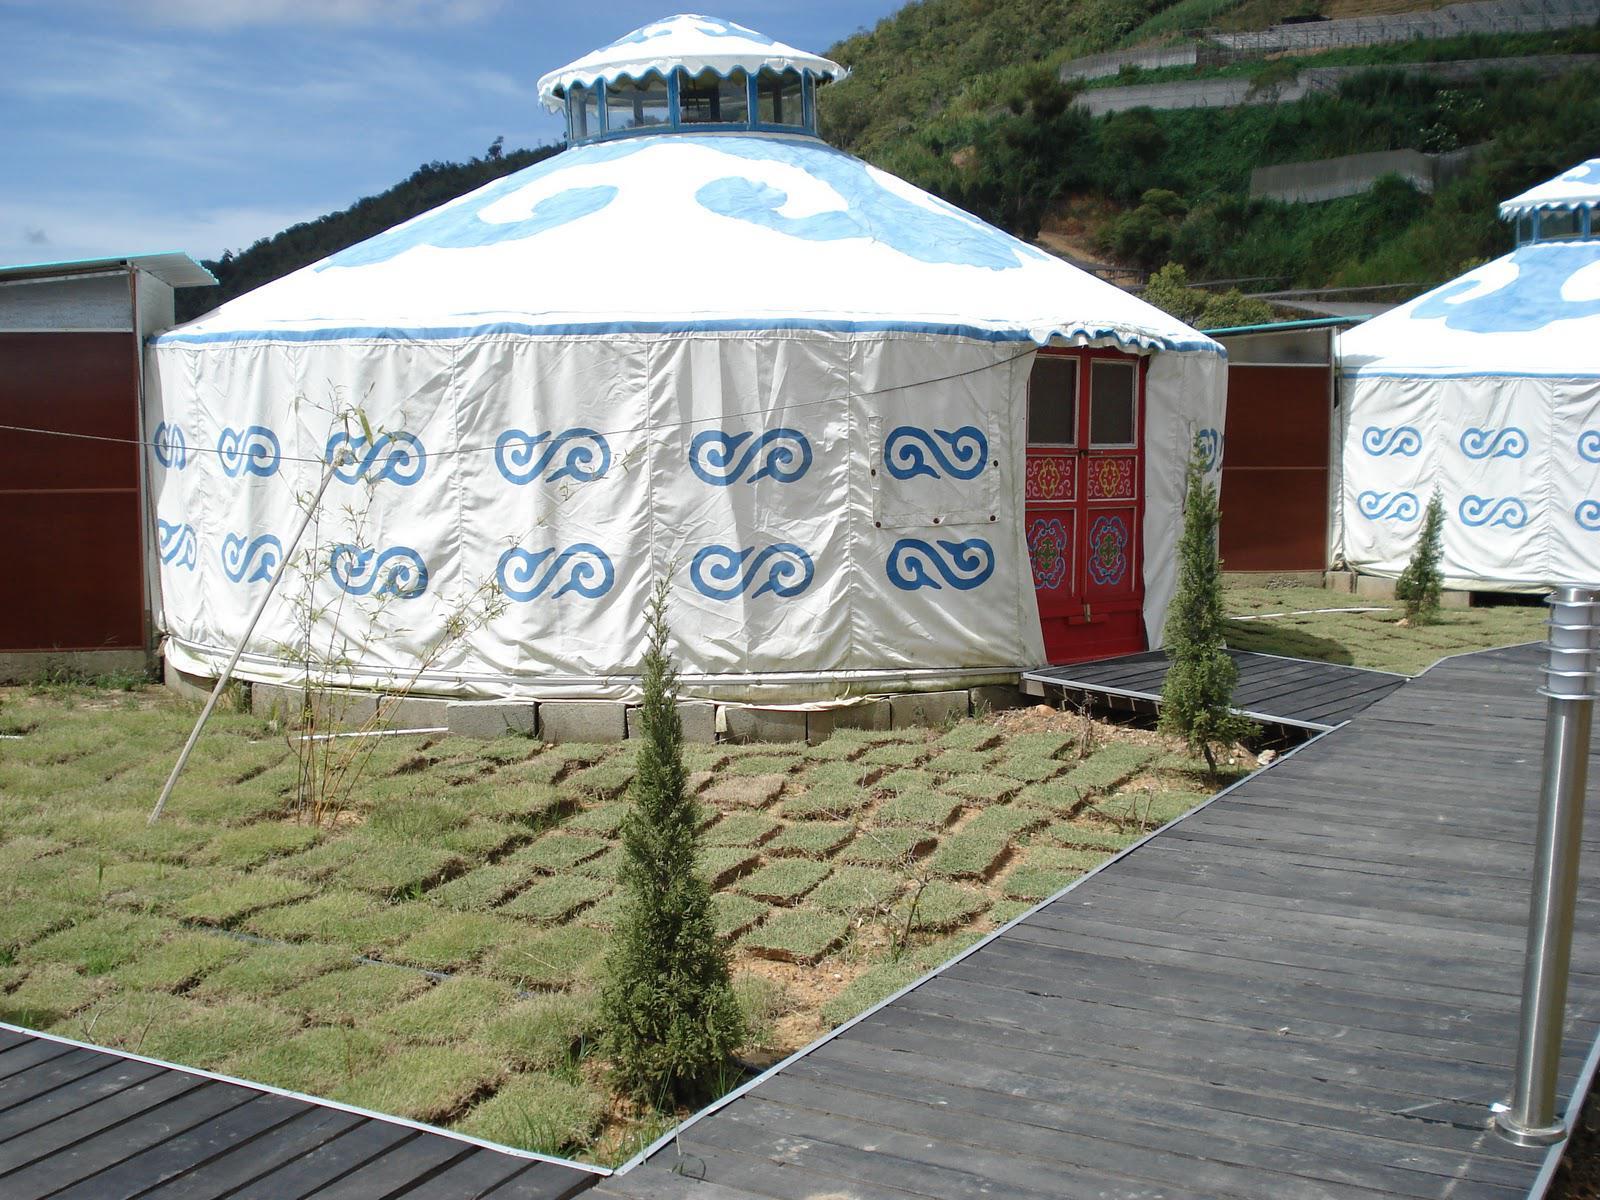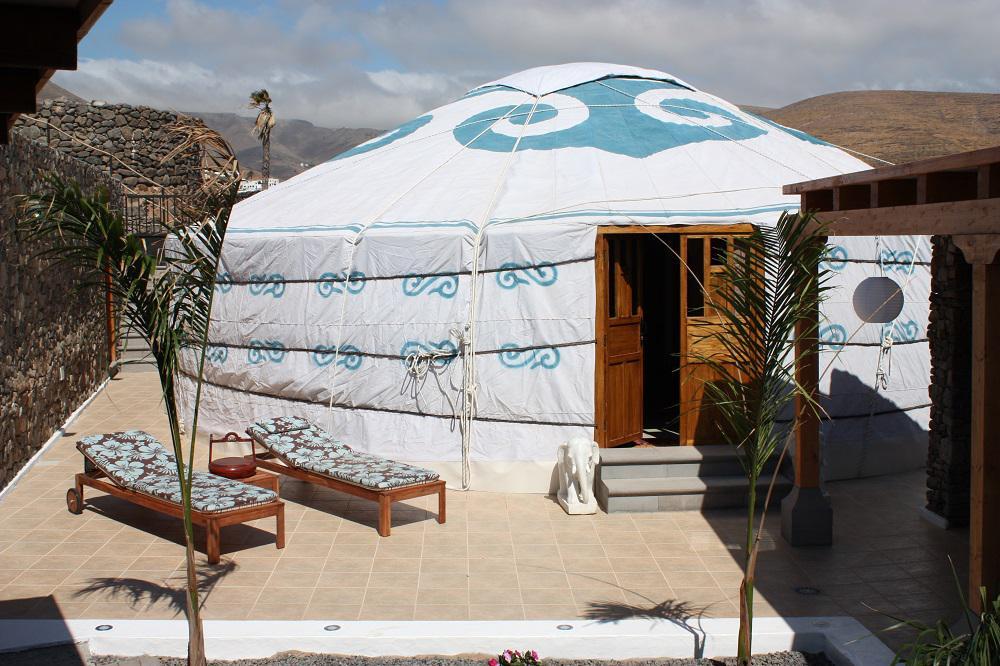The first image is the image on the left, the second image is the image on the right. For the images shown, is this caption "Both images show the exterior of a dome-topped round building, its walls covered in white with a repeating blue symbol." true? Answer yes or no. Yes. The first image is the image on the left, the second image is the image on the right. Assess this claim about the two images: "One interior image of a yurt shows a bedroom with one wide bed with a headboard and a trunk sitting at the end of the bed.". Correct or not? Answer yes or no. No. 